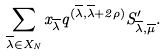Convert formula to latex. <formula><loc_0><loc_0><loc_500><loc_500>\sum _ { \overline { \lambda } \in X _ { N } } x _ { \overline { \lambda } } q ^ { ( \overline { \lambda } , \overline { \lambda } + 2 \rho ) } S _ { \overline { \lambda } , \overline { \mu } } ^ { \prime } .</formula> 